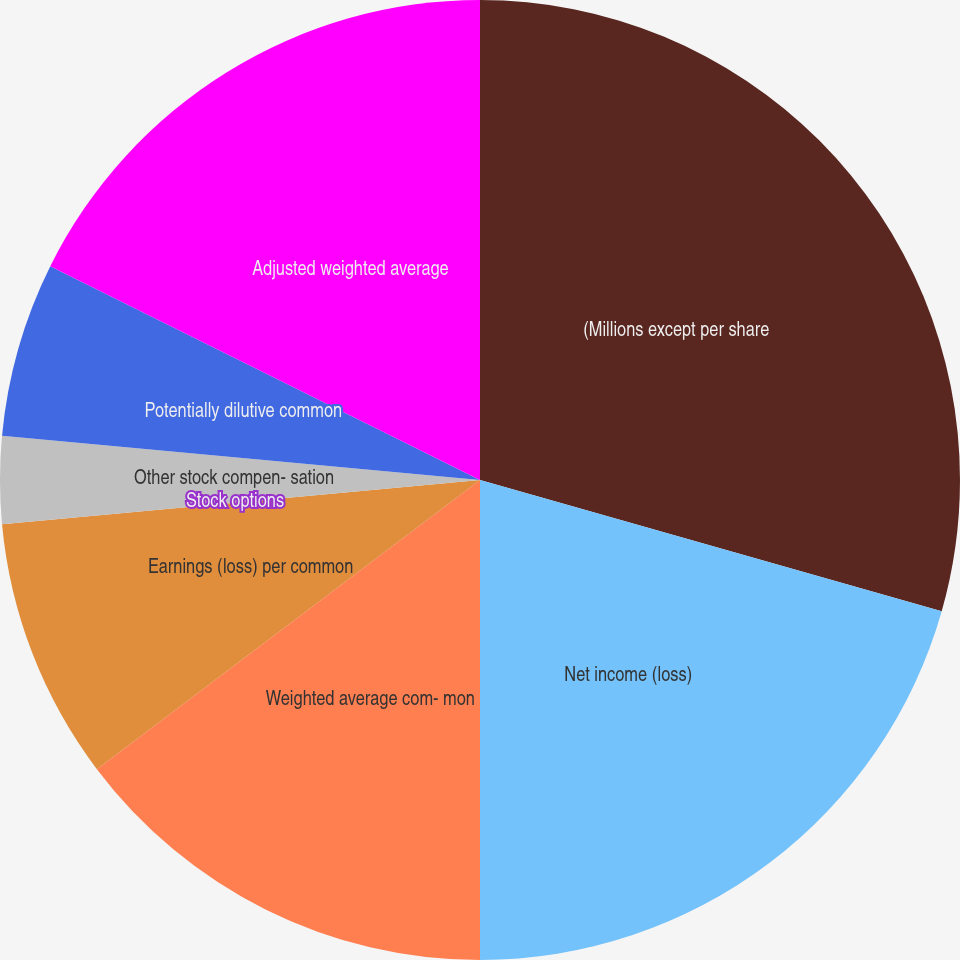<chart> <loc_0><loc_0><loc_500><loc_500><pie_chart><fcel>(Millions except per share<fcel>Net income (loss)<fcel>Weighted average com- mon<fcel>Earnings (loss) per common<fcel>Stock options<fcel>Other stock compen- sation<fcel>Potentially dilutive common<fcel>Adjusted weighted average<nl><fcel>29.41%<fcel>20.59%<fcel>14.71%<fcel>8.82%<fcel>0.0%<fcel>2.94%<fcel>5.88%<fcel>17.65%<nl></chart> 